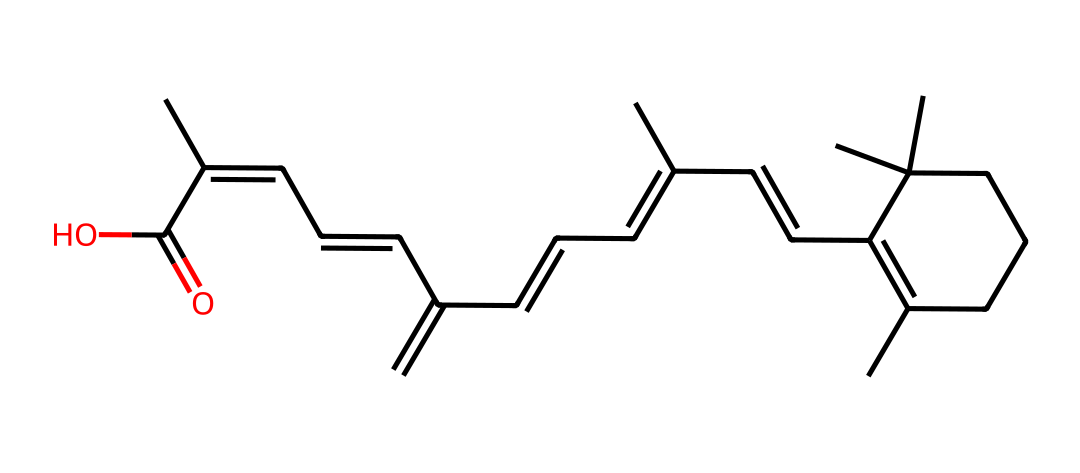What is the molecular formula of this compound? To determine the molecular formula, we can count the various atoms represented in the SMILES notation. The structure indicates multiple carbon (C) and hydrogen (H) atoms, as well as one oxygen (O) atom at the end (C(=O)O). After counting, the complete formula comes out to be C20H30O.
Answer: C20H30O How many rings are present in the structure? The structure shows two interconnected cycles made by carbon atoms, indicating the presence of two rings when visualizing the SMILES. Counting gives a total of two distinct ring structures.
Answer: 2 What is the functional group present in this compound? The functional group visible in the SMILES is a carboxylic acid group (-COOH), which is identifiable by the part C(=O)O. This indicates functionality typical of vitamin A derivatives.
Answer: carboxylic acid Which vitamin is represented by this chemical structure? Analyzing the molecular structure and its functional groups lead us to recognize that this is the structure of Vitamin A, also known as retinol.
Answer: Vitamin A What role does this vitamin play in global public health? Vitamin A is fundamental for vision, immune function, and skin health, and deficiencies can lead to serious public health issues like blindness and increased mortality in children. This explains its importance in health initiatives worldwide.
Answer: vision and immunity How many double bonds does this molecule contain? By examining the structure as provided by the SMILES notation, you can identify the presence of multiple double bonds connecting different carbon atoms. Counting these gives a total of 5 double bonds present in the structure.
Answer: 5 